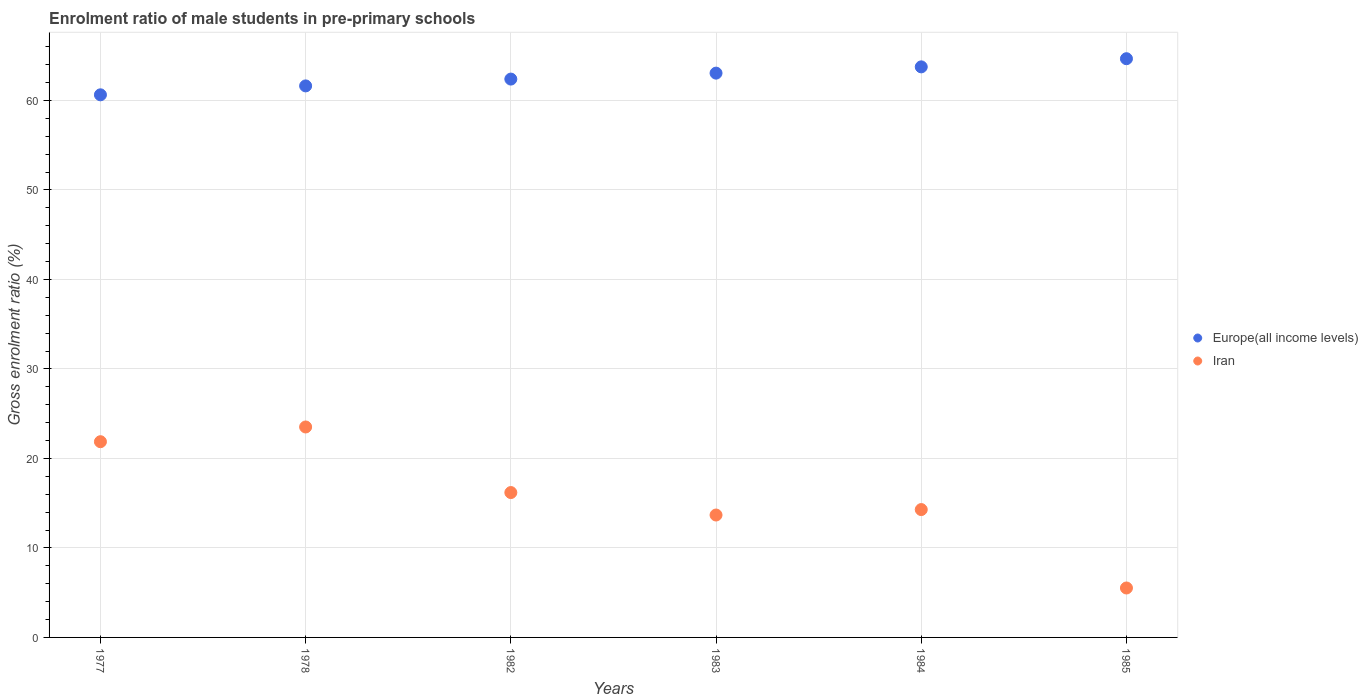How many different coloured dotlines are there?
Your response must be concise. 2. What is the enrolment ratio of male students in pre-primary schools in Europe(all income levels) in 1977?
Give a very brief answer. 60.64. Across all years, what is the maximum enrolment ratio of male students in pre-primary schools in Iran?
Offer a terse response. 23.52. Across all years, what is the minimum enrolment ratio of male students in pre-primary schools in Europe(all income levels)?
Ensure brevity in your answer.  60.64. What is the total enrolment ratio of male students in pre-primary schools in Iran in the graph?
Give a very brief answer. 95.07. What is the difference between the enrolment ratio of male students in pre-primary schools in Iran in 1978 and that in 1982?
Offer a very short reply. 7.33. What is the difference between the enrolment ratio of male students in pre-primary schools in Europe(all income levels) in 1984 and the enrolment ratio of male students in pre-primary schools in Iran in 1983?
Your response must be concise. 50.08. What is the average enrolment ratio of male students in pre-primary schools in Europe(all income levels) per year?
Ensure brevity in your answer.  62.69. In the year 1984, what is the difference between the enrolment ratio of male students in pre-primary schools in Europe(all income levels) and enrolment ratio of male students in pre-primary schools in Iran?
Keep it short and to the point. 49.47. In how many years, is the enrolment ratio of male students in pre-primary schools in Iran greater than 60 %?
Your answer should be compact. 0. What is the ratio of the enrolment ratio of male students in pre-primary schools in Europe(all income levels) in 1984 to that in 1985?
Your response must be concise. 0.99. Is the difference between the enrolment ratio of male students in pre-primary schools in Europe(all income levels) in 1984 and 1985 greater than the difference between the enrolment ratio of male students in pre-primary schools in Iran in 1984 and 1985?
Ensure brevity in your answer.  No. What is the difference between the highest and the second highest enrolment ratio of male students in pre-primary schools in Iran?
Offer a very short reply. 1.65. What is the difference between the highest and the lowest enrolment ratio of male students in pre-primary schools in Iran?
Give a very brief answer. 17.99. In how many years, is the enrolment ratio of male students in pre-primary schools in Iran greater than the average enrolment ratio of male students in pre-primary schools in Iran taken over all years?
Your answer should be very brief. 3. Does the enrolment ratio of male students in pre-primary schools in Iran monotonically increase over the years?
Offer a very short reply. No. Does the graph contain any zero values?
Offer a terse response. No. Where does the legend appear in the graph?
Your answer should be compact. Center right. How many legend labels are there?
Offer a terse response. 2. How are the legend labels stacked?
Your answer should be compact. Vertical. What is the title of the graph?
Offer a very short reply. Enrolment ratio of male students in pre-primary schools. What is the label or title of the Y-axis?
Your response must be concise. Gross enrolment ratio (%). What is the Gross enrolment ratio (%) of Europe(all income levels) in 1977?
Your answer should be very brief. 60.64. What is the Gross enrolment ratio (%) in Iran in 1977?
Your response must be concise. 21.87. What is the Gross enrolment ratio (%) in Europe(all income levels) in 1978?
Keep it short and to the point. 61.63. What is the Gross enrolment ratio (%) in Iran in 1978?
Offer a very short reply. 23.52. What is the Gross enrolment ratio (%) of Europe(all income levels) in 1982?
Provide a short and direct response. 62.39. What is the Gross enrolment ratio (%) of Iran in 1982?
Provide a succinct answer. 16.19. What is the Gross enrolment ratio (%) in Europe(all income levels) in 1983?
Provide a short and direct response. 63.06. What is the Gross enrolment ratio (%) of Iran in 1983?
Your response must be concise. 13.68. What is the Gross enrolment ratio (%) of Europe(all income levels) in 1984?
Ensure brevity in your answer.  63.76. What is the Gross enrolment ratio (%) in Iran in 1984?
Keep it short and to the point. 14.29. What is the Gross enrolment ratio (%) of Europe(all income levels) in 1985?
Your answer should be compact. 64.67. What is the Gross enrolment ratio (%) of Iran in 1985?
Your response must be concise. 5.52. Across all years, what is the maximum Gross enrolment ratio (%) in Europe(all income levels)?
Offer a terse response. 64.67. Across all years, what is the maximum Gross enrolment ratio (%) in Iran?
Your answer should be compact. 23.52. Across all years, what is the minimum Gross enrolment ratio (%) of Europe(all income levels)?
Offer a terse response. 60.64. Across all years, what is the minimum Gross enrolment ratio (%) of Iran?
Ensure brevity in your answer.  5.52. What is the total Gross enrolment ratio (%) in Europe(all income levels) in the graph?
Your answer should be compact. 376.15. What is the total Gross enrolment ratio (%) of Iran in the graph?
Make the answer very short. 95.07. What is the difference between the Gross enrolment ratio (%) of Europe(all income levels) in 1977 and that in 1978?
Provide a short and direct response. -1. What is the difference between the Gross enrolment ratio (%) of Iran in 1977 and that in 1978?
Your response must be concise. -1.65. What is the difference between the Gross enrolment ratio (%) in Europe(all income levels) in 1977 and that in 1982?
Offer a very short reply. -1.76. What is the difference between the Gross enrolment ratio (%) in Iran in 1977 and that in 1982?
Offer a very short reply. 5.68. What is the difference between the Gross enrolment ratio (%) of Europe(all income levels) in 1977 and that in 1983?
Your answer should be very brief. -2.42. What is the difference between the Gross enrolment ratio (%) in Iran in 1977 and that in 1983?
Provide a succinct answer. 8.19. What is the difference between the Gross enrolment ratio (%) in Europe(all income levels) in 1977 and that in 1984?
Your answer should be very brief. -3.12. What is the difference between the Gross enrolment ratio (%) in Iran in 1977 and that in 1984?
Ensure brevity in your answer.  7.58. What is the difference between the Gross enrolment ratio (%) of Europe(all income levels) in 1977 and that in 1985?
Offer a very short reply. -4.03. What is the difference between the Gross enrolment ratio (%) in Iran in 1977 and that in 1985?
Make the answer very short. 16.35. What is the difference between the Gross enrolment ratio (%) in Europe(all income levels) in 1978 and that in 1982?
Offer a terse response. -0.76. What is the difference between the Gross enrolment ratio (%) of Iran in 1978 and that in 1982?
Provide a short and direct response. 7.33. What is the difference between the Gross enrolment ratio (%) in Europe(all income levels) in 1978 and that in 1983?
Ensure brevity in your answer.  -1.43. What is the difference between the Gross enrolment ratio (%) of Iran in 1978 and that in 1983?
Give a very brief answer. 9.84. What is the difference between the Gross enrolment ratio (%) of Europe(all income levels) in 1978 and that in 1984?
Your answer should be very brief. -2.13. What is the difference between the Gross enrolment ratio (%) in Iran in 1978 and that in 1984?
Keep it short and to the point. 9.23. What is the difference between the Gross enrolment ratio (%) of Europe(all income levels) in 1978 and that in 1985?
Offer a terse response. -3.04. What is the difference between the Gross enrolment ratio (%) of Iran in 1978 and that in 1985?
Give a very brief answer. 17.99. What is the difference between the Gross enrolment ratio (%) in Europe(all income levels) in 1982 and that in 1983?
Give a very brief answer. -0.66. What is the difference between the Gross enrolment ratio (%) in Iran in 1982 and that in 1983?
Ensure brevity in your answer.  2.51. What is the difference between the Gross enrolment ratio (%) in Europe(all income levels) in 1982 and that in 1984?
Make the answer very short. -1.37. What is the difference between the Gross enrolment ratio (%) in Iran in 1982 and that in 1984?
Provide a succinct answer. 1.9. What is the difference between the Gross enrolment ratio (%) in Europe(all income levels) in 1982 and that in 1985?
Offer a terse response. -2.28. What is the difference between the Gross enrolment ratio (%) in Iran in 1982 and that in 1985?
Provide a succinct answer. 10.66. What is the difference between the Gross enrolment ratio (%) in Europe(all income levels) in 1983 and that in 1984?
Your answer should be compact. -0.7. What is the difference between the Gross enrolment ratio (%) in Iran in 1983 and that in 1984?
Keep it short and to the point. -0.61. What is the difference between the Gross enrolment ratio (%) of Europe(all income levels) in 1983 and that in 1985?
Offer a terse response. -1.61. What is the difference between the Gross enrolment ratio (%) in Iran in 1983 and that in 1985?
Your answer should be compact. 8.15. What is the difference between the Gross enrolment ratio (%) in Europe(all income levels) in 1984 and that in 1985?
Your response must be concise. -0.91. What is the difference between the Gross enrolment ratio (%) of Iran in 1984 and that in 1985?
Keep it short and to the point. 8.76. What is the difference between the Gross enrolment ratio (%) in Europe(all income levels) in 1977 and the Gross enrolment ratio (%) in Iran in 1978?
Provide a succinct answer. 37.12. What is the difference between the Gross enrolment ratio (%) of Europe(all income levels) in 1977 and the Gross enrolment ratio (%) of Iran in 1982?
Provide a succinct answer. 44.45. What is the difference between the Gross enrolment ratio (%) of Europe(all income levels) in 1977 and the Gross enrolment ratio (%) of Iran in 1983?
Your answer should be very brief. 46.96. What is the difference between the Gross enrolment ratio (%) of Europe(all income levels) in 1977 and the Gross enrolment ratio (%) of Iran in 1984?
Keep it short and to the point. 46.35. What is the difference between the Gross enrolment ratio (%) of Europe(all income levels) in 1977 and the Gross enrolment ratio (%) of Iran in 1985?
Your answer should be very brief. 55.11. What is the difference between the Gross enrolment ratio (%) in Europe(all income levels) in 1978 and the Gross enrolment ratio (%) in Iran in 1982?
Provide a succinct answer. 45.44. What is the difference between the Gross enrolment ratio (%) of Europe(all income levels) in 1978 and the Gross enrolment ratio (%) of Iran in 1983?
Offer a terse response. 47.95. What is the difference between the Gross enrolment ratio (%) of Europe(all income levels) in 1978 and the Gross enrolment ratio (%) of Iran in 1984?
Make the answer very short. 47.34. What is the difference between the Gross enrolment ratio (%) in Europe(all income levels) in 1978 and the Gross enrolment ratio (%) in Iran in 1985?
Keep it short and to the point. 56.11. What is the difference between the Gross enrolment ratio (%) in Europe(all income levels) in 1982 and the Gross enrolment ratio (%) in Iran in 1983?
Give a very brief answer. 48.71. What is the difference between the Gross enrolment ratio (%) of Europe(all income levels) in 1982 and the Gross enrolment ratio (%) of Iran in 1984?
Offer a very short reply. 48.11. What is the difference between the Gross enrolment ratio (%) in Europe(all income levels) in 1982 and the Gross enrolment ratio (%) in Iran in 1985?
Provide a short and direct response. 56.87. What is the difference between the Gross enrolment ratio (%) in Europe(all income levels) in 1983 and the Gross enrolment ratio (%) in Iran in 1984?
Your response must be concise. 48.77. What is the difference between the Gross enrolment ratio (%) in Europe(all income levels) in 1983 and the Gross enrolment ratio (%) in Iran in 1985?
Your response must be concise. 57.53. What is the difference between the Gross enrolment ratio (%) in Europe(all income levels) in 1984 and the Gross enrolment ratio (%) in Iran in 1985?
Offer a very short reply. 58.23. What is the average Gross enrolment ratio (%) of Europe(all income levels) per year?
Keep it short and to the point. 62.69. What is the average Gross enrolment ratio (%) of Iran per year?
Keep it short and to the point. 15.84. In the year 1977, what is the difference between the Gross enrolment ratio (%) of Europe(all income levels) and Gross enrolment ratio (%) of Iran?
Your response must be concise. 38.76. In the year 1978, what is the difference between the Gross enrolment ratio (%) of Europe(all income levels) and Gross enrolment ratio (%) of Iran?
Give a very brief answer. 38.11. In the year 1982, what is the difference between the Gross enrolment ratio (%) of Europe(all income levels) and Gross enrolment ratio (%) of Iran?
Your answer should be very brief. 46.2. In the year 1983, what is the difference between the Gross enrolment ratio (%) in Europe(all income levels) and Gross enrolment ratio (%) in Iran?
Your answer should be very brief. 49.38. In the year 1984, what is the difference between the Gross enrolment ratio (%) in Europe(all income levels) and Gross enrolment ratio (%) in Iran?
Keep it short and to the point. 49.47. In the year 1985, what is the difference between the Gross enrolment ratio (%) in Europe(all income levels) and Gross enrolment ratio (%) in Iran?
Give a very brief answer. 59.15. What is the ratio of the Gross enrolment ratio (%) in Europe(all income levels) in 1977 to that in 1978?
Your response must be concise. 0.98. What is the ratio of the Gross enrolment ratio (%) in Iran in 1977 to that in 1978?
Your response must be concise. 0.93. What is the ratio of the Gross enrolment ratio (%) of Europe(all income levels) in 1977 to that in 1982?
Your response must be concise. 0.97. What is the ratio of the Gross enrolment ratio (%) in Iran in 1977 to that in 1982?
Ensure brevity in your answer.  1.35. What is the ratio of the Gross enrolment ratio (%) in Europe(all income levels) in 1977 to that in 1983?
Give a very brief answer. 0.96. What is the ratio of the Gross enrolment ratio (%) of Iran in 1977 to that in 1983?
Your answer should be very brief. 1.6. What is the ratio of the Gross enrolment ratio (%) in Europe(all income levels) in 1977 to that in 1984?
Your answer should be compact. 0.95. What is the ratio of the Gross enrolment ratio (%) in Iran in 1977 to that in 1984?
Provide a succinct answer. 1.53. What is the ratio of the Gross enrolment ratio (%) of Europe(all income levels) in 1977 to that in 1985?
Provide a succinct answer. 0.94. What is the ratio of the Gross enrolment ratio (%) of Iran in 1977 to that in 1985?
Ensure brevity in your answer.  3.96. What is the ratio of the Gross enrolment ratio (%) in Iran in 1978 to that in 1982?
Ensure brevity in your answer.  1.45. What is the ratio of the Gross enrolment ratio (%) of Europe(all income levels) in 1978 to that in 1983?
Provide a succinct answer. 0.98. What is the ratio of the Gross enrolment ratio (%) of Iran in 1978 to that in 1983?
Ensure brevity in your answer.  1.72. What is the ratio of the Gross enrolment ratio (%) of Europe(all income levels) in 1978 to that in 1984?
Keep it short and to the point. 0.97. What is the ratio of the Gross enrolment ratio (%) in Iran in 1978 to that in 1984?
Your answer should be compact. 1.65. What is the ratio of the Gross enrolment ratio (%) of Europe(all income levels) in 1978 to that in 1985?
Give a very brief answer. 0.95. What is the ratio of the Gross enrolment ratio (%) in Iran in 1978 to that in 1985?
Your answer should be compact. 4.26. What is the ratio of the Gross enrolment ratio (%) of Iran in 1982 to that in 1983?
Provide a succinct answer. 1.18. What is the ratio of the Gross enrolment ratio (%) of Europe(all income levels) in 1982 to that in 1984?
Give a very brief answer. 0.98. What is the ratio of the Gross enrolment ratio (%) in Iran in 1982 to that in 1984?
Offer a terse response. 1.13. What is the ratio of the Gross enrolment ratio (%) of Europe(all income levels) in 1982 to that in 1985?
Offer a terse response. 0.96. What is the ratio of the Gross enrolment ratio (%) in Iran in 1982 to that in 1985?
Offer a very short reply. 2.93. What is the ratio of the Gross enrolment ratio (%) in Iran in 1983 to that in 1984?
Make the answer very short. 0.96. What is the ratio of the Gross enrolment ratio (%) of Europe(all income levels) in 1983 to that in 1985?
Your answer should be compact. 0.98. What is the ratio of the Gross enrolment ratio (%) in Iran in 1983 to that in 1985?
Your answer should be compact. 2.48. What is the ratio of the Gross enrolment ratio (%) of Europe(all income levels) in 1984 to that in 1985?
Make the answer very short. 0.99. What is the ratio of the Gross enrolment ratio (%) of Iran in 1984 to that in 1985?
Provide a succinct answer. 2.59. What is the difference between the highest and the second highest Gross enrolment ratio (%) in Europe(all income levels)?
Give a very brief answer. 0.91. What is the difference between the highest and the second highest Gross enrolment ratio (%) of Iran?
Ensure brevity in your answer.  1.65. What is the difference between the highest and the lowest Gross enrolment ratio (%) in Europe(all income levels)?
Your response must be concise. 4.03. What is the difference between the highest and the lowest Gross enrolment ratio (%) in Iran?
Your answer should be compact. 17.99. 